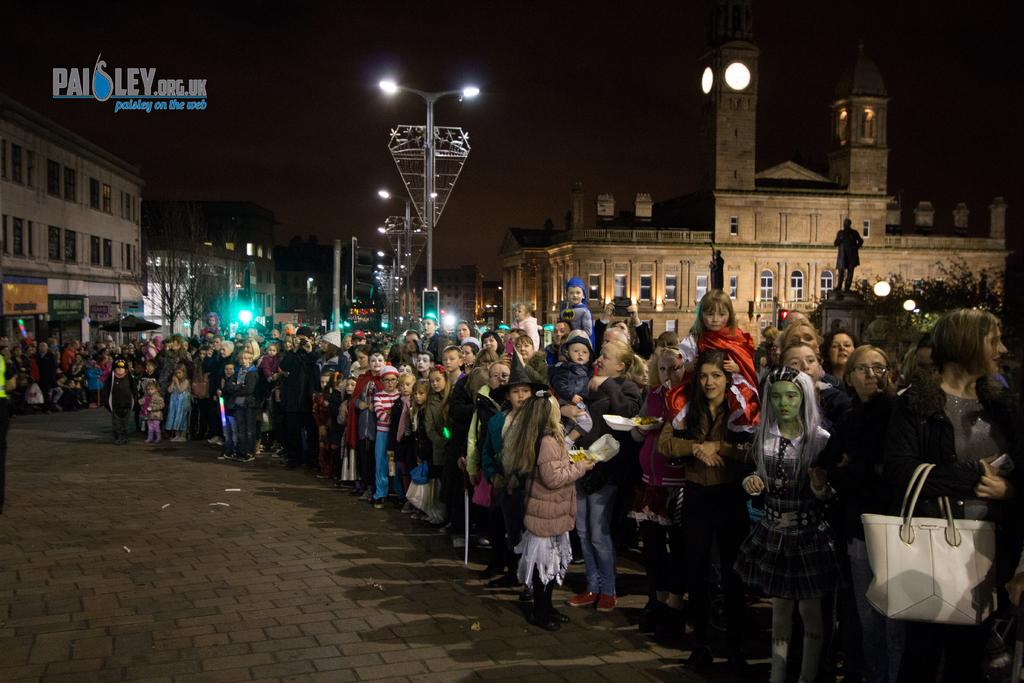What is happening with the group of people in the image? The people are standing and waiting for something. What can be seen in the background of the image? There are buildings, trees, street lights, and a statue in the background of the image. What type of hook is hanging from the statue in the image? There is no hook present on the statue in the image. What date is marked on the calendar in the image? There is no calendar present in the image. 